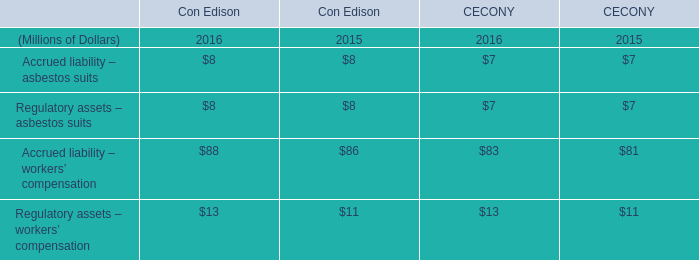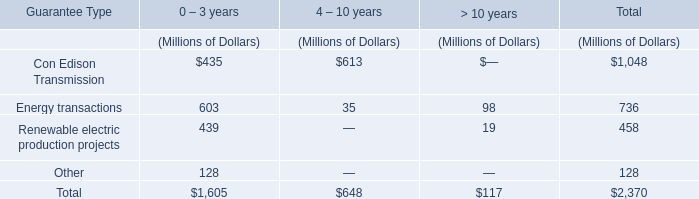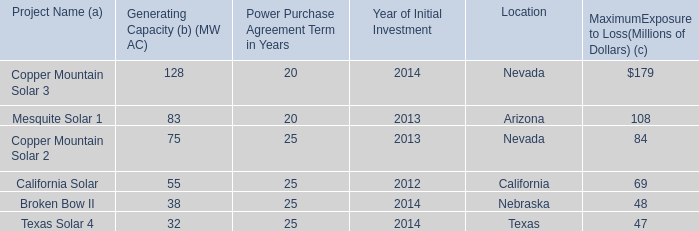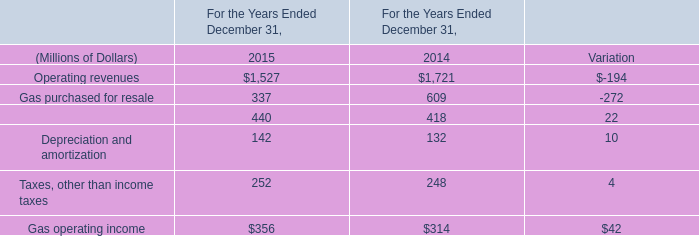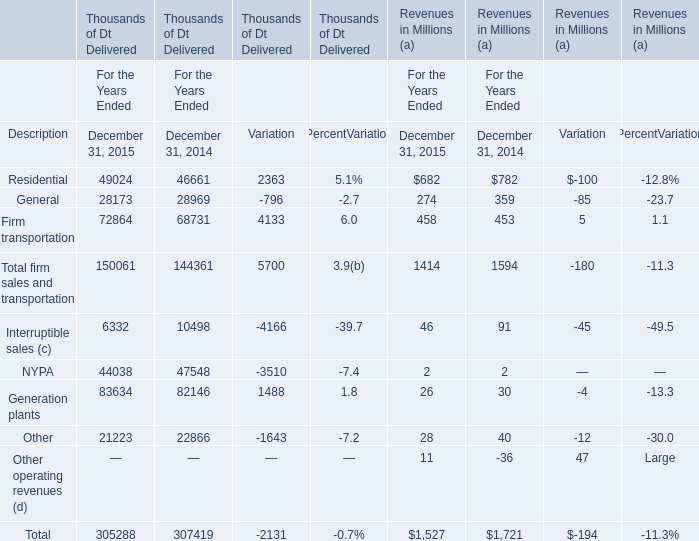What's the difference of Residential Revenues for the years ended between 2015 and 2014? (in million) 
Computations: (682 - 782)
Answer: -100.0. 